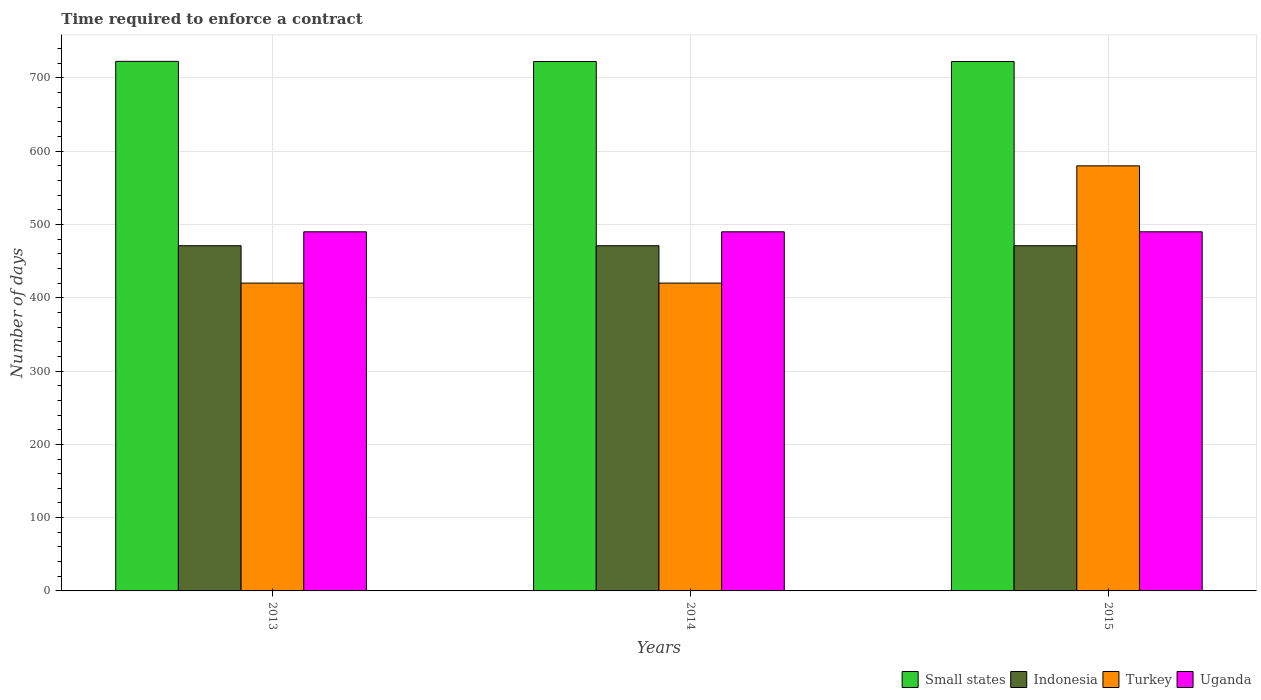Are the number of bars per tick equal to the number of legend labels?
Provide a short and direct response. Yes. How many bars are there on the 1st tick from the left?
Your answer should be very brief. 4. What is the label of the 3rd group of bars from the left?
Make the answer very short. 2015. What is the number of days required to enforce a contract in Turkey in 2015?
Ensure brevity in your answer.  580. Across all years, what is the maximum number of days required to enforce a contract in Small states?
Your answer should be compact. 722.58. Across all years, what is the minimum number of days required to enforce a contract in Indonesia?
Make the answer very short. 471. In which year was the number of days required to enforce a contract in Small states minimum?
Keep it short and to the point. 2014. What is the total number of days required to enforce a contract in Indonesia in the graph?
Provide a short and direct response. 1413. What is the difference between the number of days required to enforce a contract in Indonesia in 2014 and the number of days required to enforce a contract in Turkey in 2013?
Provide a short and direct response. 51. What is the average number of days required to enforce a contract in Turkey per year?
Offer a very short reply. 473.33. In the year 2014, what is the difference between the number of days required to enforce a contract in Small states and number of days required to enforce a contract in Indonesia?
Provide a short and direct response. 251.33. In how many years, is the number of days required to enforce a contract in Uganda greater than 200 days?
Your answer should be compact. 3. Is the number of days required to enforce a contract in Uganda in 2013 less than that in 2014?
Offer a terse response. No. What is the difference between the highest and the second highest number of days required to enforce a contract in Small states?
Offer a very short reply. 0.25. Is it the case that in every year, the sum of the number of days required to enforce a contract in Indonesia and number of days required to enforce a contract in Small states is greater than the sum of number of days required to enforce a contract in Uganda and number of days required to enforce a contract in Turkey?
Give a very brief answer. Yes. What does the 2nd bar from the left in 2013 represents?
Ensure brevity in your answer.  Indonesia. What does the 3rd bar from the right in 2014 represents?
Provide a short and direct response. Indonesia. Is it the case that in every year, the sum of the number of days required to enforce a contract in Indonesia and number of days required to enforce a contract in Small states is greater than the number of days required to enforce a contract in Uganda?
Give a very brief answer. Yes. How many bars are there?
Keep it short and to the point. 12. Are all the bars in the graph horizontal?
Your answer should be very brief. No. How many years are there in the graph?
Keep it short and to the point. 3. What is the difference between two consecutive major ticks on the Y-axis?
Offer a very short reply. 100. Are the values on the major ticks of Y-axis written in scientific E-notation?
Your answer should be compact. No. Does the graph contain any zero values?
Make the answer very short. No. Where does the legend appear in the graph?
Your answer should be very brief. Bottom right. How many legend labels are there?
Your answer should be compact. 4. What is the title of the graph?
Offer a terse response. Time required to enforce a contract. Does "Latvia" appear as one of the legend labels in the graph?
Your answer should be very brief. No. What is the label or title of the Y-axis?
Make the answer very short. Number of days. What is the Number of days of Small states in 2013?
Offer a terse response. 722.58. What is the Number of days of Indonesia in 2013?
Your answer should be very brief. 471. What is the Number of days in Turkey in 2013?
Give a very brief answer. 420. What is the Number of days of Uganda in 2013?
Your answer should be compact. 490. What is the Number of days in Small states in 2014?
Ensure brevity in your answer.  722.33. What is the Number of days in Indonesia in 2014?
Give a very brief answer. 471. What is the Number of days in Turkey in 2014?
Make the answer very short. 420. What is the Number of days of Uganda in 2014?
Offer a very short reply. 490. What is the Number of days of Small states in 2015?
Provide a short and direct response. 722.33. What is the Number of days of Indonesia in 2015?
Keep it short and to the point. 471. What is the Number of days in Turkey in 2015?
Your response must be concise. 580. What is the Number of days of Uganda in 2015?
Provide a short and direct response. 490. Across all years, what is the maximum Number of days of Small states?
Keep it short and to the point. 722.58. Across all years, what is the maximum Number of days in Indonesia?
Ensure brevity in your answer.  471. Across all years, what is the maximum Number of days of Turkey?
Provide a short and direct response. 580. Across all years, what is the maximum Number of days in Uganda?
Offer a terse response. 490. Across all years, what is the minimum Number of days in Small states?
Keep it short and to the point. 722.33. Across all years, what is the minimum Number of days of Indonesia?
Your answer should be compact. 471. Across all years, what is the minimum Number of days in Turkey?
Offer a terse response. 420. Across all years, what is the minimum Number of days in Uganda?
Keep it short and to the point. 490. What is the total Number of days in Small states in the graph?
Your answer should be very brief. 2167.22. What is the total Number of days of Indonesia in the graph?
Give a very brief answer. 1413. What is the total Number of days of Turkey in the graph?
Provide a succinct answer. 1420. What is the total Number of days of Uganda in the graph?
Provide a short and direct response. 1470. What is the difference between the Number of days in Small states in 2013 and that in 2014?
Offer a very short reply. 0.25. What is the difference between the Number of days of Indonesia in 2013 and that in 2015?
Provide a short and direct response. 0. What is the difference between the Number of days in Turkey in 2013 and that in 2015?
Your answer should be compact. -160. What is the difference between the Number of days in Small states in 2014 and that in 2015?
Your answer should be compact. 0. What is the difference between the Number of days in Indonesia in 2014 and that in 2015?
Keep it short and to the point. 0. What is the difference between the Number of days of Turkey in 2014 and that in 2015?
Offer a terse response. -160. What is the difference between the Number of days of Small states in 2013 and the Number of days of Indonesia in 2014?
Make the answer very short. 251.57. What is the difference between the Number of days of Small states in 2013 and the Number of days of Turkey in 2014?
Ensure brevity in your answer.  302.57. What is the difference between the Number of days in Small states in 2013 and the Number of days in Uganda in 2014?
Give a very brief answer. 232.57. What is the difference between the Number of days of Indonesia in 2013 and the Number of days of Uganda in 2014?
Provide a succinct answer. -19. What is the difference between the Number of days in Turkey in 2013 and the Number of days in Uganda in 2014?
Keep it short and to the point. -70. What is the difference between the Number of days in Small states in 2013 and the Number of days in Indonesia in 2015?
Ensure brevity in your answer.  251.57. What is the difference between the Number of days of Small states in 2013 and the Number of days of Turkey in 2015?
Your response must be concise. 142.57. What is the difference between the Number of days of Small states in 2013 and the Number of days of Uganda in 2015?
Ensure brevity in your answer.  232.57. What is the difference between the Number of days in Indonesia in 2013 and the Number of days in Turkey in 2015?
Make the answer very short. -109. What is the difference between the Number of days of Turkey in 2013 and the Number of days of Uganda in 2015?
Provide a short and direct response. -70. What is the difference between the Number of days in Small states in 2014 and the Number of days in Indonesia in 2015?
Ensure brevity in your answer.  251.32. What is the difference between the Number of days of Small states in 2014 and the Number of days of Turkey in 2015?
Give a very brief answer. 142.32. What is the difference between the Number of days of Small states in 2014 and the Number of days of Uganda in 2015?
Your answer should be compact. 232.32. What is the difference between the Number of days in Indonesia in 2014 and the Number of days in Turkey in 2015?
Give a very brief answer. -109. What is the difference between the Number of days of Indonesia in 2014 and the Number of days of Uganda in 2015?
Offer a very short reply. -19. What is the difference between the Number of days in Turkey in 2014 and the Number of days in Uganda in 2015?
Make the answer very short. -70. What is the average Number of days in Small states per year?
Give a very brief answer. 722.41. What is the average Number of days in Indonesia per year?
Offer a terse response. 471. What is the average Number of days in Turkey per year?
Keep it short and to the point. 473.33. What is the average Number of days of Uganda per year?
Give a very brief answer. 490. In the year 2013, what is the difference between the Number of days in Small states and Number of days in Indonesia?
Your response must be concise. 251.57. In the year 2013, what is the difference between the Number of days in Small states and Number of days in Turkey?
Make the answer very short. 302.57. In the year 2013, what is the difference between the Number of days of Small states and Number of days of Uganda?
Your response must be concise. 232.57. In the year 2013, what is the difference between the Number of days in Turkey and Number of days in Uganda?
Ensure brevity in your answer.  -70. In the year 2014, what is the difference between the Number of days in Small states and Number of days in Indonesia?
Ensure brevity in your answer.  251.32. In the year 2014, what is the difference between the Number of days in Small states and Number of days in Turkey?
Give a very brief answer. 302.32. In the year 2014, what is the difference between the Number of days of Small states and Number of days of Uganda?
Give a very brief answer. 232.32. In the year 2014, what is the difference between the Number of days of Indonesia and Number of days of Turkey?
Offer a terse response. 51. In the year 2014, what is the difference between the Number of days of Indonesia and Number of days of Uganda?
Offer a very short reply. -19. In the year 2014, what is the difference between the Number of days in Turkey and Number of days in Uganda?
Offer a terse response. -70. In the year 2015, what is the difference between the Number of days of Small states and Number of days of Indonesia?
Your answer should be very brief. 251.32. In the year 2015, what is the difference between the Number of days of Small states and Number of days of Turkey?
Provide a short and direct response. 142.32. In the year 2015, what is the difference between the Number of days of Small states and Number of days of Uganda?
Give a very brief answer. 232.32. In the year 2015, what is the difference between the Number of days in Indonesia and Number of days in Turkey?
Provide a short and direct response. -109. In the year 2015, what is the difference between the Number of days in Indonesia and Number of days in Uganda?
Ensure brevity in your answer.  -19. In the year 2015, what is the difference between the Number of days of Turkey and Number of days of Uganda?
Your answer should be compact. 90. What is the ratio of the Number of days in Small states in 2013 to that in 2014?
Provide a succinct answer. 1. What is the ratio of the Number of days in Turkey in 2013 to that in 2014?
Provide a short and direct response. 1. What is the ratio of the Number of days in Small states in 2013 to that in 2015?
Your response must be concise. 1. What is the ratio of the Number of days in Turkey in 2013 to that in 2015?
Make the answer very short. 0.72. What is the ratio of the Number of days in Small states in 2014 to that in 2015?
Offer a terse response. 1. What is the ratio of the Number of days in Turkey in 2014 to that in 2015?
Your answer should be compact. 0.72. What is the difference between the highest and the second highest Number of days of Small states?
Give a very brief answer. 0.25. What is the difference between the highest and the second highest Number of days of Indonesia?
Make the answer very short. 0. What is the difference between the highest and the second highest Number of days in Turkey?
Make the answer very short. 160. What is the difference between the highest and the lowest Number of days in Indonesia?
Keep it short and to the point. 0. What is the difference between the highest and the lowest Number of days of Turkey?
Provide a succinct answer. 160. What is the difference between the highest and the lowest Number of days in Uganda?
Make the answer very short. 0. 